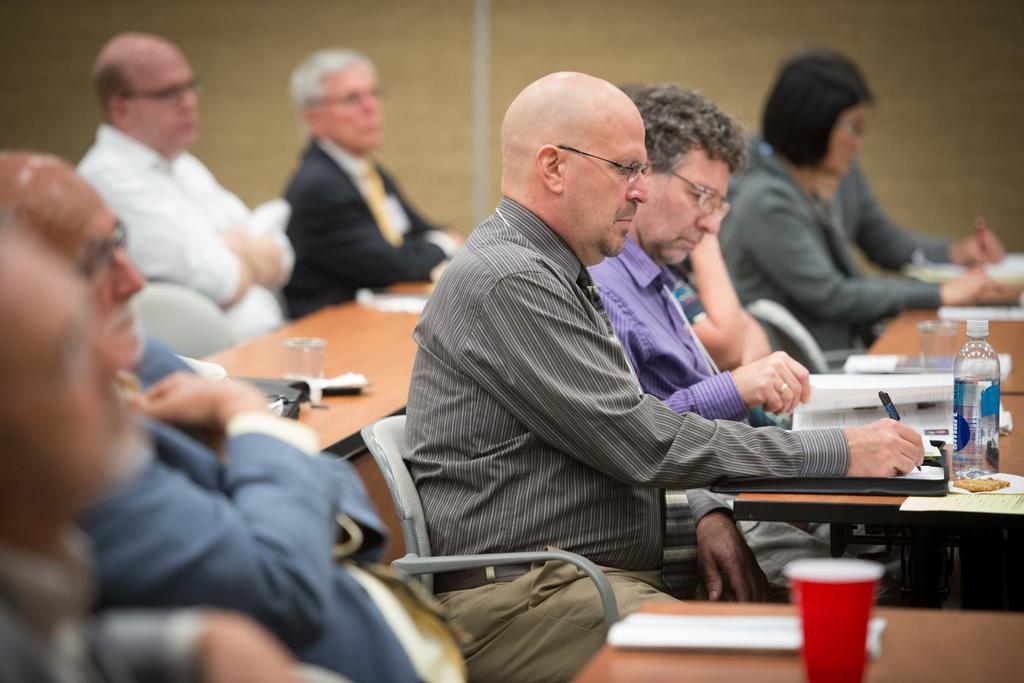How many people are in the image? There is a group of persons in the image. What are the persons doing in the image? The persons are doing some work. What are the persons sitting on while doing their work? The persons are sitting on chairs. Who is wearing a crown in the image? There is no crown present in the image. How many eggs are visible in the image? There are no eggs visible in the image. 